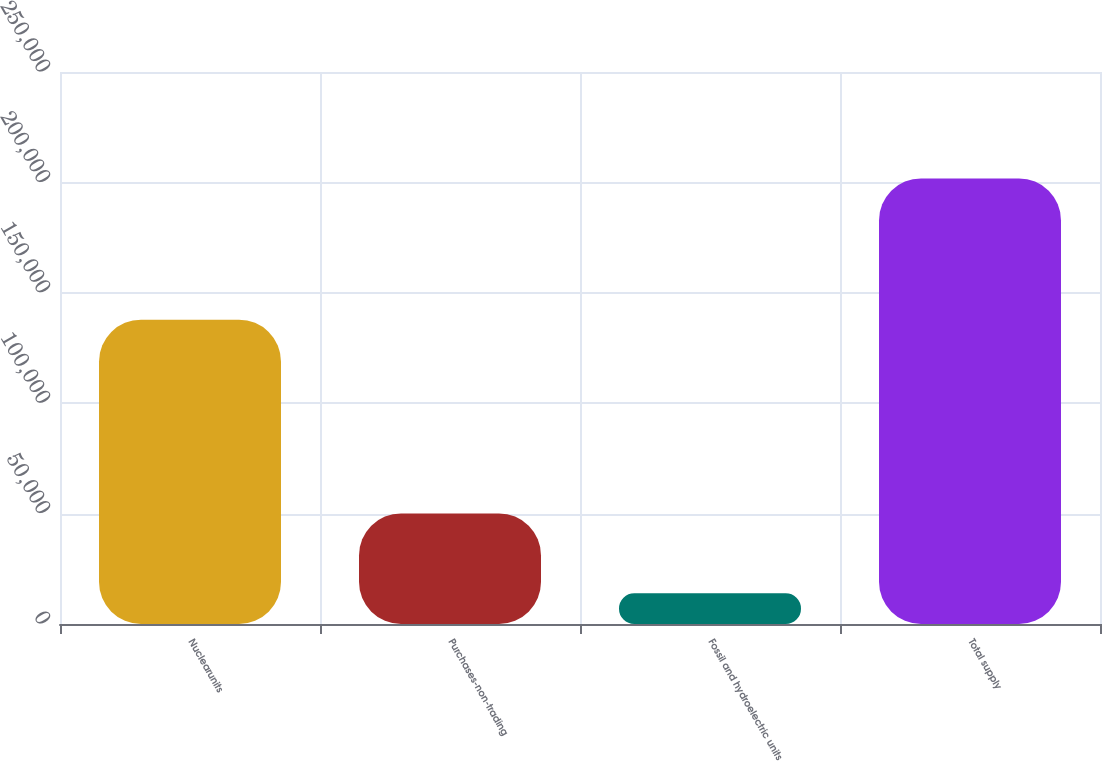Convert chart to OTSL. <chart><loc_0><loc_0><loc_500><loc_500><bar_chart><fcel>Nuclearunits<fcel>Purchases-non-trading<fcel>Fossil and hydroelectric units<fcel>Total supply<nl><fcel>137832<fcel>50098<fcel>13891<fcel>201821<nl></chart> 